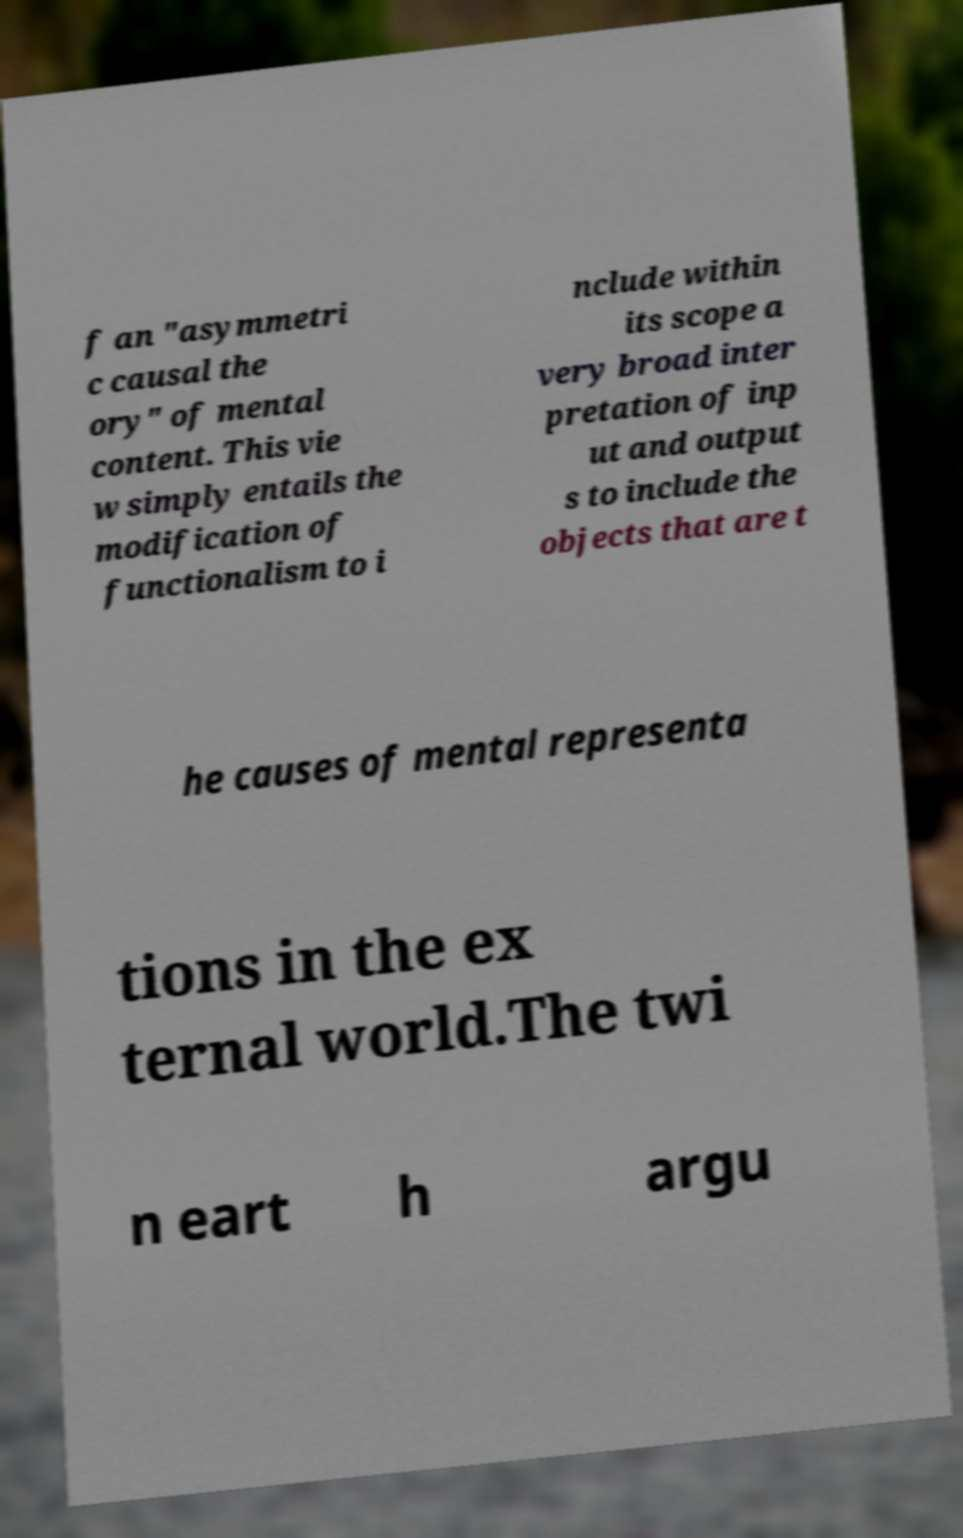Could you extract and type out the text from this image? f an "asymmetri c causal the ory" of mental content. This vie w simply entails the modification of functionalism to i nclude within its scope a very broad inter pretation of inp ut and output s to include the objects that are t he causes of mental representa tions in the ex ternal world.The twi n eart h argu 